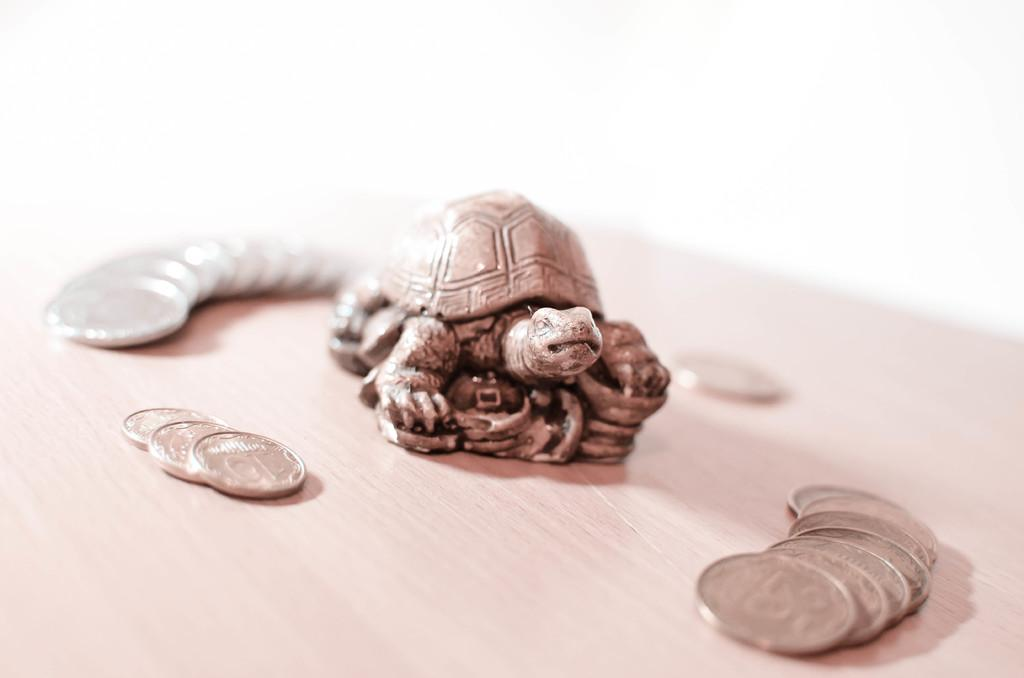What type of animal is featured in the decorative item in the image? There is a decorative tortoise in the image. What else can be seen on the table in the image? Coins are present in the image. Where are the decorative tortoise and coins located in the image? Both the decorative tortoise and coins are on a table. What hobbies are the members of this society engaged in within the image? There is no reference to a society or any hobbies in the image; it features a decorative tortoise and coins on a table. 